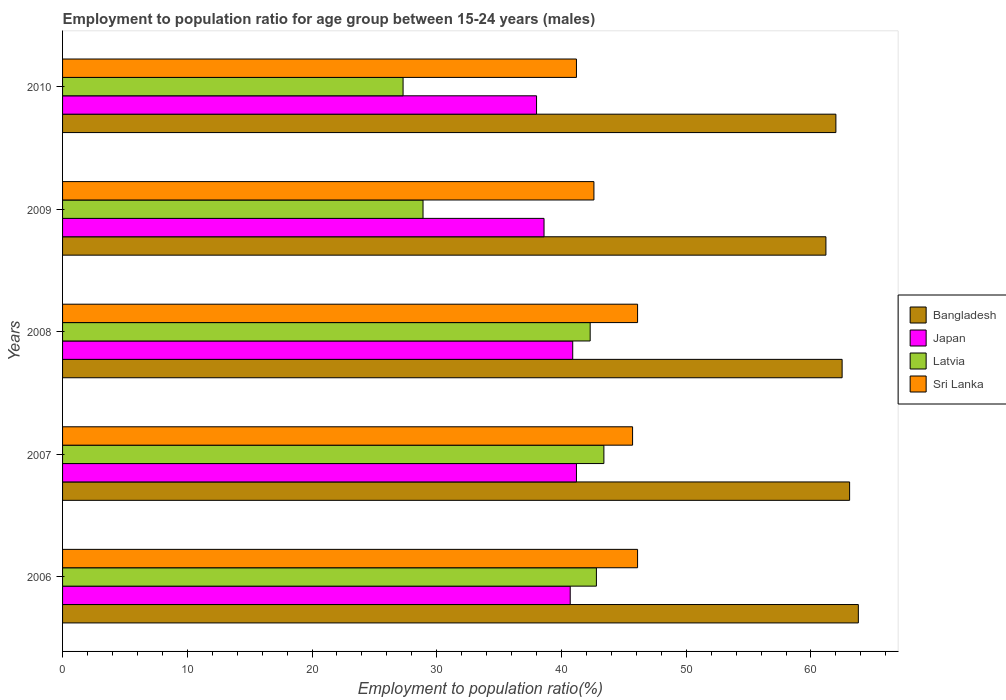Are the number of bars per tick equal to the number of legend labels?
Ensure brevity in your answer.  Yes. Are the number of bars on each tick of the Y-axis equal?
Give a very brief answer. Yes. In how many cases, is the number of bars for a given year not equal to the number of legend labels?
Ensure brevity in your answer.  0. What is the employment to population ratio in Sri Lanka in 2008?
Your answer should be compact. 46.1. Across all years, what is the maximum employment to population ratio in Sri Lanka?
Your answer should be compact. 46.1. Across all years, what is the minimum employment to population ratio in Bangladesh?
Give a very brief answer. 61.2. In which year was the employment to population ratio in Latvia minimum?
Your response must be concise. 2010. What is the total employment to population ratio in Latvia in the graph?
Offer a very short reply. 184.7. What is the difference between the employment to population ratio in Sri Lanka in 2006 and that in 2007?
Your answer should be very brief. 0.4. What is the difference between the employment to population ratio in Sri Lanka in 2010 and the employment to population ratio in Bangladesh in 2006?
Provide a short and direct response. -22.6. What is the average employment to population ratio in Japan per year?
Provide a short and direct response. 39.88. In the year 2007, what is the difference between the employment to population ratio in Latvia and employment to population ratio in Bangladesh?
Make the answer very short. -19.7. In how many years, is the employment to population ratio in Japan greater than 42 %?
Provide a short and direct response. 0. What is the ratio of the employment to population ratio in Sri Lanka in 2006 to that in 2009?
Offer a very short reply. 1.08. Is the employment to population ratio in Latvia in 2006 less than that in 2009?
Provide a succinct answer. No. What is the difference between the highest and the second highest employment to population ratio in Latvia?
Keep it short and to the point. 0.6. What is the difference between the highest and the lowest employment to population ratio in Bangladesh?
Ensure brevity in your answer.  2.6. In how many years, is the employment to population ratio in Japan greater than the average employment to population ratio in Japan taken over all years?
Your answer should be compact. 3. Is the sum of the employment to population ratio in Latvia in 2007 and 2008 greater than the maximum employment to population ratio in Bangladesh across all years?
Make the answer very short. Yes. Is it the case that in every year, the sum of the employment to population ratio in Japan and employment to population ratio in Sri Lanka is greater than the sum of employment to population ratio in Latvia and employment to population ratio in Bangladesh?
Offer a very short reply. No. What does the 3rd bar from the top in 2008 represents?
Ensure brevity in your answer.  Japan. What does the 4th bar from the bottom in 2009 represents?
Offer a very short reply. Sri Lanka. Is it the case that in every year, the sum of the employment to population ratio in Sri Lanka and employment to population ratio in Latvia is greater than the employment to population ratio in Japan?
Your response must be concise. Yes. How many bars are there?
Your answer should be compact. 20. Are all the bars in the graph horizontal?
Provide a succinct answer. Yes. Does the graph contain grids?
Provide a succinct answer. No. Where does the legend appear in the graph?
Give a very brief answer. Center right. What is the title of the graph?
Your answer should be compact. Employment to population ratio for age group between 15-24 years (males). What is the label or title of the Y-axis?
Ensure brevity in your answer.  Years. What is the Employment to population ratio(%) of Bangladesh in 2006?
Your response must be concise. 63.8. What is the Employment to population ratio(%) of Japan in 2006?
Ensure brevity in your answer.  40.7. What is the Employment to population ratio(%) in Latvia in 2006?
Your answer should be very brief. 42.8. What is the Employment to population ratio(%) of Sri Lanka in 2006?
Give a very brief answer. 46.1. What is the Employment to population ratio(%) in Bangladesh in 2007?
Make the answer very short. 63.1. What is the Employment to population ratio(%) of Japan in 2007?
Make the answer very short. 41.2. What is the Employment to population ratio(%) in Latvia in 2007?
Give a very brief answer. 43.4. What is the Employment to population ratio(%) of Sri Lanka in 2007?
Provide a succinct answer. 45.7. What is the Employment to population ratio(%) of Bangladesh in 2008?
Give a very brief answer. 62.5. What is the Employment to population ratio(%) in Japan in 2008?
Your response must be concise. 40.9. What is the Employment to population ratio(%) of Latvia in 2008?
Make the answer very short. 42.3. What is the Employment to population ratio(%) of Sri Lanka in 2008?
Offer a terse response. 46.1. What is the Employment to population ratio(%) of Bangladesh in 2009?
Offer a very short reply. 61.2. What is the Employment to population ratio(%) of Japan in 2009?
Offer a very short reply. 38.6. What is the Employment to population ratio(%) in Latvia in 2009?
Provide a succinct answer. 28.9. What is the Employment to population ratio(%) of Sri Lanka in 2009?
Provide a short and direct response. 42.6. What is the Employment to population ratio(%) in Latvia in 2010?
Provide a succinct answer. 27.3. What is the Employment to population ratio(%) of Sri Lanka in 2010?
Provide a short and direct response. 41.2. Across all years, what is the maximum Employment to population ratio(%) of Bangladesh?
Your answer should be compact. 63.8. Across all years, what is the maximum Employment to population ratio(%) in Japan?
Your answer should be compact. 41.2. Across all years, what is the maximum Employment to population ratio(%) in Latvia?
Your answer should be very brief. 43.4. Across all years, what is the maximum Employment to population ratio(%) of Sri Lanka?
Keep it short and to the point. 46.1. Across all years, what is the minimum Employment to population ratio(%) of Bangladesh?
Ensure brevity in your answer.  61.2. Across all years, what is the minimum Employment to population ratio(%) of Latvia?
Offer a terse response. 27.3. Across all years, what is the minimum Employment to population ratio(%) in Sri Lanka?
Ensure brevity in your answer.  41.2. What is the total Employment to population ratio(%) in Bangladesh in the graph?
Offer a very short reply. 312.6. What is the total Employment to population ratio(%) of Japan in the graph?
Your answer should be compact. 199.4. What is the total Employment to population ratio(%) of Latvia in the graph?
Offer a very short reply. 184.7. What is the total Employment to population ratio(%) of Sri Lanka in the graph?
Make the answer very short. 221.7. What is the difference between the Employment to population ratio(%) in Japan in 2006 and that in 2007?
Offer a very short reply. -0.5. What is the difference between the Employment to population ratio(%) in Sri Lanka in 2006 and that in 2007?
Your answer should be compact. 0.4. What is the difference between the Employment to population ratio(%) in Latvia in 2006 and that in 2008?
Provide a short and direct response. 0.5. What is the difference between the Employment to population ratio(%) in Sri Lanka in 2006 and that in 2008?
Your response must be concise. 0. What is the difference between the Employment to population ratio(%) in Bangladesh in 2006 and that in 2009?
Offer a very short reply. 2.6. What is the difference between the Employment to population ratio(%) in Japan in 2006 and that in 2009?
Ensure brevity in your answer.  2.1. What is the difference between the Employment to population ratio(%) of Latvia in 2006 and that in 2009?
Provide a succinct answer. 13.9. What is the difference between the Employment to population ratio(%) of Sri Lanka in 2006 and that in 2009?
Keep it short and to the point. 3.5. What is the difference between the Employment to population ratio(%) of Sri Lanka in 2006 and that in 2010?
Provide a succinct answer. 4.9. What is the difference between the Employment to population ratio(%) in Bangladesh in 2007 and that in 2008?
Provide a short and direct response. 0.6. What is the difference between the Employment to population ratio(%) in Sri Lanka in 2007 and that in 2008?
Provide a succinct answer. -0.4. What is the difference between the Employment to population ratio(%) in Bangladesh in 2007 and that in 2009?
Your response must be concise. 1.9. What is the difference between the Employment to population ratio(%) of Bangladesh in 2007 and that in 2010?
Offer a very short reply. 1.1. What is the difference between the Employment to population ratio(%) of Japan in 2007 and that in 2010?
Provide a succinct answer. 3.2. What is the difference between the Employment to population ratio(%) of Bangladesh in 2008 and that in 2010?
Offer a terse response. 0.5. What is the difference between the Employment to population ratio(%) in Japan in 2008 and that in 2010?
Provide a short and direct response. 2.9. What is the difference between the Employment to population ratio(%) in Sri Lanka in 2008 and that in 2010?
Offer a very short reply. 4.9. What is the difference between the Employment to population ratio(%) of Bangladesh in 2009 and that in 2010?
Offer a terse response. -0.8. What is the difference between the Employment to population ratio(%) of Sri Lanka in 2009 and that in 2010?
Your answer should be very brief. 1.4. What is the difference between the Employment to population ratio(%) in Bangladesh in 2006 and the Employment to population ratio(%) in Japan in 2007?
Ensure brevity in your answer.  22.6. What is the difference between the Employment to population ratio(%) in Bangladesh in 2006 and the Employment to population ratio(%) in Latvia in 2007?
Your answer should be very brief. 20.4. What is the difference between the Employment to population ratio(%) of Bangladesh in 2006 and the Employment to population ratio(%) of Sri Lanka in 2007?
Your response must be concise. 18.1. What is the difference between the Employment to population ratio(%) in Japan in 2006 and the Employment to population ratio(%) in Latvia in 2007?
Offer a very short reply. -2.7. What is the difference between the Employment to population ratio(%) in Bangladesh in 2006 and the Employment to population ratio(%) in Japan in 2008?
Keep it short and to the point. 22.9. What is the difference between the Employment to population ratio(%) in Latvia in 2006 and the Employment to population ratio(%) in Sri Lanka in 2008?
Your answer should be very brief. -3.3. What is the difference between the Employment to population ratio(%) in Bangladesh in 2006 and the Employment to population ratio(%) in Japan in 2009?
Make the answer very short. 25.2. What is the difference between the Employment to population ratio(%) in Bangladesh in 2006 and the Employment to population ratio(%) in Latvia in 2009?
Keep it short and to the point. 34.9. What is the difference between the Employment to population ratio(%) of Bangladesh in 2006 and the Employment to population ratio(%) of Sri Lanka in 2009?
Provide a short and direct response. 21.2. What is the difference between the Employment to population ratio(%) in Japan in 2006 and the Employment to population ratio(%) in Sri Lanka in 2009?
Provide a succinct answer. -1.9. What is the difference between the Employment to population ratio(%) in Latvia in 2006 and the Employment to population ratio(%) in Sri Lanka in 2009?
Give a very brief answer. 0.2. What is the difference between the Employment to population ratio(%) of Bangladesh in 2006 and the Employment to population ratio(%) of Japan in 2010?
Your response must be concise. 25.8. What is the difference between the Employment to population ratio(%) in Bangladesh in 2006 and the Employment to population ratio(%) in Latvia in 2010?
Provide a short and direct response. 36.5. What is the difference between the Employment to population ratio(%) of Bangladesh in 2006 and the Employment to population ratio(%) of Sri Lanka in 2010?
Ensure brevity in your answer.  22.6. What is the difference between the Employment to population ratio(%) of Japan in 2006 and the Employment to population ratio(%) of Latvia in 2010?
Your answer should be very brief. 13.4. What is the difference between the Employment to population ratio(%) in Bangladesh in 2007 and the Employment to population ratio(%) in Japan in 2008?
Provide a succinct answer. 22.2. What is the difference between the Employment to population ratio(%) in Bangladesh in 2007 and the Employment to population ratio(%) in Latvia in 2008?
Your response must be concise. 20.8. What is the difference between the Employment to population ratio(%) of Latvia in 2007 and the Employment to population ratio(%) of Sri Lanka in 2008?
Keep it short and to the point. -2.7. What is the difference between the Employment to population ratio(%) of Bangladesh in 2007 and the Employment to population ratio(%) of Latvia in 2009?
Offer a terse response. 34.2. What is the difference between the Employment to population ratio(%) of Bangladesh in 2007 and the Employment to population ratio(%) of Sri Lanka in 2009?
Your answer should be very brief. 20.5. What is the difference between the Employment to population ratio(%) of Latvia in 2007 and the Employment to population ratio(%) of Sri Lanka in 2009?
Provide a short and direct response. 0.8. What is the difference between the Employment to population ratio(%) in Bangladesh in 2007 and the Employment to population ratio(%) in Japan in 2010?
Give a very brief answer. 25.1. What is the difference between the Employment to population ratio(%) of Bangladesh in 2007 and the Employment to population ratio(%) of Latvia in 2010?
Make the answer very short. 35.8. What is the difference between the Employment to population ratio(%) of Bangladesh in 2007 and the Employment to population ratio(%) of Sri Lanka in 2010?
Your answer should be very brief. 21.9. What is the difference between the Employment to population ratio(%) of Latvia in 2007 and the Employment to population ratio(%) of Sri Lanka in 2010?
Offer a terse response. 2.2. What is the difference between the Employment to population ratio(%) of Bangladesh in 2008 and the Employment to population ratio(%) of Japan in 2009?
Offer a very short reply. 23.9. What is the difference between the Employment to population ratio(%) of Bangladesh in 2008 and the Employment to population ratio(%) of Latvia in 2009?
Your answer should be compact. 33.6. What is the difference between the Employment to population ratio(%) of Japan in 2008 and the Employment to population ratio(%) of Latvia in 2009?
Keep it short and to the point. 12. What is the difference between the Employment to population ratio(%) of Bangladesh in 2008 and the Employment to population ratio(%) of Latvia in 2010?
Your answer should be compact. 35.2. What is the difference between the Employment to population ratio(%) in Bangladesh in 2008 and the Employment to population ratio(%) in Sri Lanka in 2010?
Ensure brevity in your answer.  21.3. What is the difference between the Employment to population ratio(%) of Japan in 2008 and the Employment to population ratio(%) of Sri Lanka in 2010?
Your response must be concise. -0.3. What is the difference between the Employment to population ratio(%) of Bangladesh in 2009 and the Employment to population ratio(%) of Japan in 2010?
Offer a very short reply. 23.2. What is the difference between the Employment to population ratio(%) of Bangladesh in 2009 and the Employment to population ratio(%) of Latvia in 2010?
Make the answer very short. 33.9. What is the difference between the Employment to population ratio(%) in Japan in 2009 and the Employment to population ratio(%) in Latvia in 2010?
Your answer should be compact. 11.3. What is the difference between the Employment to population ratio(%) in Japan in 2009 and the Employment to population ratio(%) in Sri Lanka in 2010?
Provide a short and direct response. -2.6. What is the average Employment to population ratio(%) in Bangladesh per year?
Give a very brief answer. 62.52. What is the average Employment to population ratio(%) of Japan per year?
Offer a very short reply. 39.88. What is the average Employment to population ratio(%) in Latvia per year?
Offer a terse response. 36.94. What is the average Employment to population ratio(%) in Sri Lanka per year?
Your answer should be compact. 44.34. In the year 2006, what is the difference between the Employment to population ratio(%) of Bangladesh and Employment to population ratio(%) of Japan?
Provide a succinct answer. 23.1. In the year 2006, what is the difference between the Employment to population ratio(%) of Bangladesh and Employment to population ratio(%) of Latvia?
Keep it short and to the point. 21. In the year 2006, what is the difference between the Employment to population ratio(%) in Japan and Employment to population ratio(%) in Latvia?
Make the answer very short. -2.1. In the year 2006, what is the difference between the Employment to population ratio(%) of Japan and Employment to population ratio(%) of Sri Lanka?
Provide a succinct answer. -5.4. In the year 2006, what is the difference between the Employment to population ratio(%) of Latvia and Employment to population ratio(%) of Sri Lanka?
Your answer should be very brief. -3.3. In the year 2007, what is the difference between the Employment to population ratio(%) in Bangladesh and Employment to population ratio(%) in Japan?
Ensure brevity in your answer.  21.9. In the year 2007, what is the difference between the Employment to population ratio(%) in Bangladesh and Employment to population ratio(%) in Sri Lanka?
Provide a succinct answer. 17.4. In the year 2008, what is the difference between the Employment to population ratio(%) of Bangladesh and Employment to population ratio(%) of Japan?
Provide a succinct answer. 21.6. In the year 2008, what is the difference between the Employment to population ratio(%) in Bangladesh and Employment to population ratio(%) in Latvia?
Make the answer very short. 20.2. In the year 2008, what is the difference between the Employment to population ratio(%) in Bangladesh and Employment to population ratio(%) in Sri Lanka?
Offer a very short reply. 16.4. In the year 2008, what is the difference between the Employment to population ratio(%) in Japan and Employment to population ratio(%) in Latvia?
Keep it short and to the point. -1.4. In the year 2008, what is the difference between the Employment to population ratio(%) of Latvia and Employment to population ratio(%) of Sri Lanka?
Your answer should be very brief. -3.8. In the year 2009, what is the difference between the Employment to population ratio(%) in Bangladesh and Employment to population ratio(%) in Japan?
Give a very brief answer. 22.6. In the year 2009, what is the difference between the Employment to population ratio(%) in Bangladesh and Employment to population ratio(%) in Latvia?
Offer a terse response. 32.3. In the year 2009, what is the difference between the Employment to population ratio(%) in Bangladesh and Employment to population ratio(%) in Sri Lanka?
Your answer should be very brief. 18.6. In the year 2009, what is the difference between the Employment to population ratio(%) of Japan and Employment to population ratio(%) of Latvia?
Your response must be concise. 9.7. In the year 2009, what is the difference between the Employment to population ratio(%) in Latvia and Employment to population ratio(%) in Sri Lanka?
Offer a very short reply. -13.7. In the year 2010, what is the difference between the Employment to population ratio(%) in Bangladesh and Employment to population ratio(%) in Latvia?
Keep it short and to the point. 34.7. In the year 2010, what is the difference between the Employment to population ratio(%) of Bangladesh and Employment to population ratio(%) of Sri Lanka?
Ensure brevity in your answer.  20.8. In the year 2010, what is the difference between the Employment to population ratio(%) in Japan and Employment to population ratio(%) in Latvia?
Keep it short and to the point. 10.7. In the year 2010, what is the difference between the Employment to population ratio(%) of Latvia and Employment to population ratio(%) of Sri Lanka?
Your answer should be compact. -13.9. What is the ratio of the Employment to population ratio(%) in Bangladesh in 2006 to that in 2007?
Your answer should be very brief. 1.01. What is the ratio of the Employment to population ratio(%) in Japan in 2006 to that in 2007?
Your response must be concise. 0.99. What is the ratio of the Employment to population ratio(%) in Latvia in 2006 to that in 2007?
Your response must be concise. 0.99. What is the ratio of the Employment to population ratio(%) of Sri Lanka in 2006 to that in 2007?
Provide a succinct answer. 1.01. What is the ratio of the Employment to population ratio(%) in Bangladesh in 2006 to that in 2008?
Provide a succinct answer. 1.02. What is the ratio of the Employment to population ratio(%) of Japan in 2006 to that in 2008?
Keep it short and to the point. 1. What is the ratio of the Employment to population ratio(%) in Latvia in 2006 to that in 2008?
Make the answer very short. 1.01. What is the ratio of the Employment to population ratio(%) of Sri Lanka in 2006 to that in 2008?
Offer a very short reply. 1. What is the ratio of the Employment to population ratio(%) in Bangladesh in 2006 to that in 2009?
Your answer should be very brief. 1.04. What is the ratio of the Employment to population ratio(%) in Japan in 2006 to that in 2009?
Give a very brief answer. 1.05. What is the ratio of the Employment to population ratio(%) of Latvia in 2006 to that in 2009?
Keep it short and to the point. 1.48. What is the ratio of the Employment to population ratio(%) in Sri Lanka in 2006 to that in 2009?
Your response must be concise. 1.08. What is the ratio of the Employment to population ratio(%) of Japan in 2006 to that in 2010?
Offer a terse response. 1.07. What is the ratio of the Employment to population ratio(%) of Latvia in 2006 to that in 2010?
Make the answer very short. 1.57. What is the ratio of the Employment to population ratio(%) in Sri Lanka in 2006 to that in 2010?
Your response must be concise. 1.12. What is the ratio of the Employment to population ratio(%) in Bangladesh in 2007 to that in 2008?
Ensure brevity in your answer.  1.01. What is the ratio of the Employment to population ratio(%) in Japan in 2007 to that in 2008?
Provide a short and direct response. 1.01. What is the ratio of the Employment to population ratio(%) of Sri Lanka in 2007 to that in 2008?
Your answer should be very brief. 0.99. What is the ratio of the Employment to population ratio(%) of Bangladesh in 2007 to that in 2009?
Make the answer very short. 1.03. What is the ratio of the Employment to population ratio(%) of Japan in 2007 to that in 2009?
Give a very brief answer. 1.07. What is the ratio of the Employment to population ratio(%) of Latvia in 2007 to that in 2009?
Offer a terse response. 1.5. What is the ratio of the Employment to population ratio(%) of Sri Lanka in 2007 to that in 2009?
Ensure brevity in your answer.  1.07. What is the ratio of the Employment to population ratio(%) in Bangladesh in 2007 to that in 2010?
Keep it short and to the point. 1.02. What is the ratio of the Employment to population ratio(%) of Japan in 2007 to that in 2010?
Provide a short and direct response. 1.08. What is the ratio of the Employment to population ratio(%) in Latvia in 2007 to that in 2010?
Give a very brief answer. 1.59. What is the ratio of the Employment to population ratio(%) in Sri Lanka in 2007 to that in 2010?
Ensure brevity in your answer.  1.11. What is the ratio of the Employment to population ratio(%) in Bangladesh in 2008 to that in 2009?
Give a very brief answer. 1.02. What is the ratio of the Employment to population ratio(%) of Japan in 2008 to that in 2009?
Your answer should be very brief. 1.06. What is the ratio of the Employment to population ratio(%) in Latvia in 2008 to that in 2009?
Ensure brevity in your answer.  1.46. What is the ratio of the Employment to population ratio(%) of Sri Lanka in 2008 to that in 2009?
Your answer should be compact. 1.08. What is the ratio of the Employment to population ratio(%) in Japan in 2008 to that in 2010?
Provide a short and direct response. 1.08. What is the ratio of the Employment to population ratio(%) of Latvia in 2008 to that in 2010?
Your answer should be compact. 1.55. What is the ratio of the Employment to population ratio(%) in Sri Lanka in 2008 to that in 2010?
Offer a very short reply. 1.12. What is the ratio of the Employment to population ratio(%) in Bangladesh in 2009 to that in 2010?
Your response must be concise. 0.99. What is the ratio of the Employment to population ratio(%) in Japan in 2009 to that in 2010?
Offer a terse response. 1.02. What is the ratio of the Employment to population ratio(%) in Latvia in 2009 to that in 2010?
Offer a very short reply. 1.06. What is the ratio of the Employment to population ratio(%) in Sri Lanka in 2009 to that in 2010?
Offer a very short reply. 1.03. What is the difference between the highest and the second highest Employment to population ratio(%) in Bangladesh?
Ensure brevity in your answer.  0.7. What is the difference between the highest and the lowest Employment to population ratio(%) of Latvia?
Offer a terse response. 16.1. 